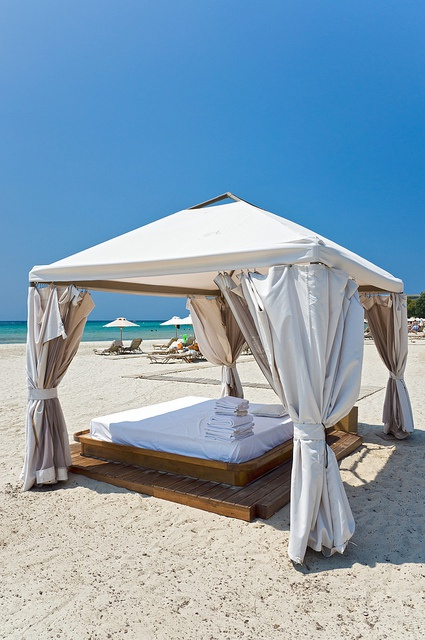Describe the objects in this image and their specific colors. I can see bed in lightblue, darkgray, maroon, and white tones, umbrella in lightblue, white, and teal tones, chair in lightblue, white, gray, and tan tones, umbrella in lightblue, white, teal, darkgray, and gray tones, and chair in lightblue, gray, and darkgray tones in this image. 